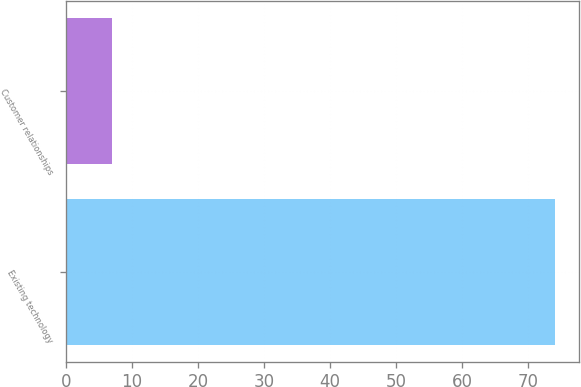Convert chart to OTSL. <chart><loc_0><loc_0><loc_500><loc_500><bar_chart><fcel>Existing technology<fcel>Customer relationships<nl><fcel>74<fcel>7<nl></chart> 